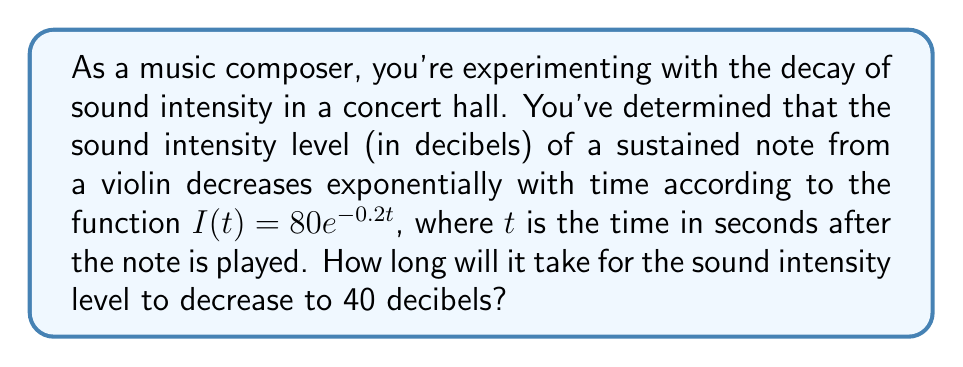Help me with this question. To solve this problem, we need to use the exponential decay function given and solve for t when I(t) = 40 decibels.

1) We start with the equation: $I(t) = 80e^{-0.2t}$

2) We want to find t when I(t) = 40, so we set up the equation:
   $40 = 80e^{-0.2t}$

3) Divide both sides by 80:
   $\frac{40}{80} = e^{-0.2t}$
   $0.5 = e^{-0.2t}$

4) Take the natural logarithm of both sides:
   $\ln(0.5) = \ln(e^{-0.2t})$

5) Simplify the right side using the properties of logarithms:
   $\ln(0.5) = -0.2t$

6) Solve for t:
   $t = -\frac{\ln(0.5)}{0.2}$

7) Calculate the result:
   $t = -\frac{-0.69314718}{0.2} \approx 3.46573590$ seconds

Therefore, it will take approximately 3.47 seconds for the sound intensity level to decrease to 40 decibels.
Answer: $t \approx 3.47$ seconds 